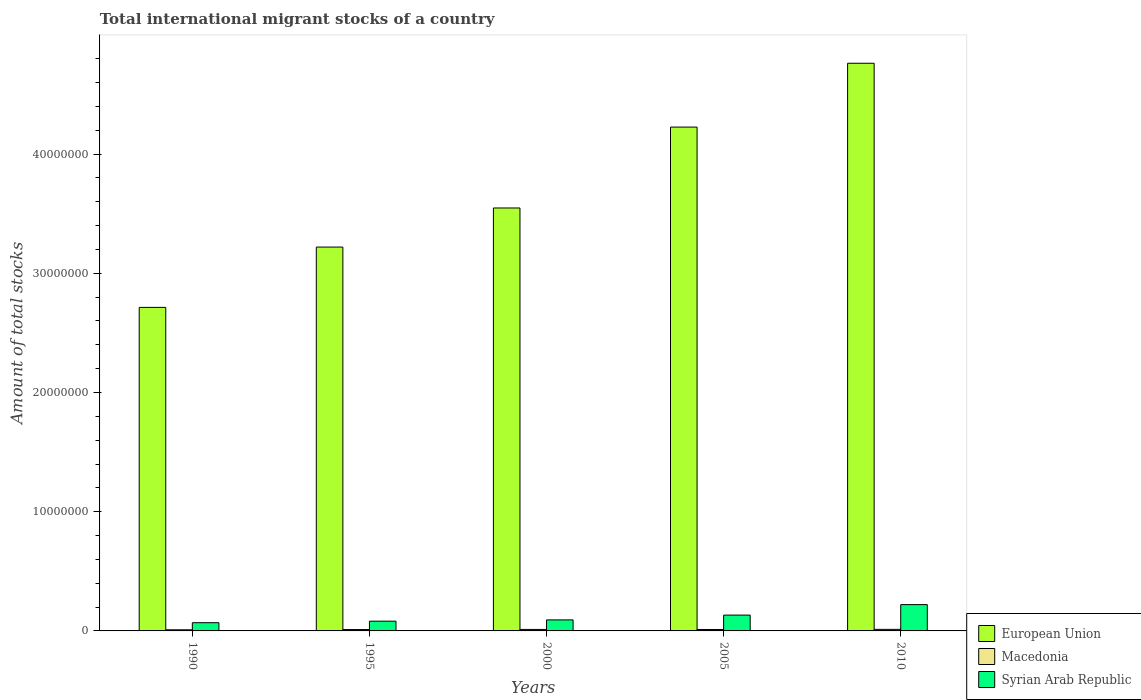How many different coloured bars are there?
Make the answer very short. 3. Are the number of bars per tick equal to the number of legend labels?
Your answer should be compact. Yes. Are the number of bars on each tick of the X-axis equal?
Provide a short and direct response. Yes. How many bars are there on the 2nd tick from the right?
Offer a terse response. 3. What is the amount of total stocks in in Syrian Arab Republic in 1990?
Provide a short and direct response. 6.90e+05. Across all years, what is the maximum amount of total stocks in in Macedonia?
Provide a succinct answer. 1.30e+05. Across all years, what is the minimum amount of total stocks in in Macedonia?
Provide a succinct answer. 9.51e+04. In which year was the amount of total stocks in in European Union minimum?
Give a very brief answer. 1990. What is the total amount of total stocks in in Macedonia in the graph?
Make the answer very short. 5.85e+05. What is the difference between the amount of total stocks in in Syrian Arab Republic in 1995 and that in 2005?
Give a very brief answer. -5.10e+05. What is the difference between the amount of total stocks in in European Union in 2010 and the amount of total stocks in in Macedonia in 1990?
Your response must be concise. 4.75e+07. What is the average amount of total stocks in in European Union per year?
Provide a succinct answer. 3.69e+07. In the year 1995, what is the difference between the amount of total stocks in in European Union and amount of total stocks in in Syrian Arab Republic?
Your response must be concise. 3.14e+07. What is the ratio of the amount of total stocks in in European Union in 1990 to that in 2010?
Offer a terse response. 0.57. Is the amount of total stocks in in European Union in 1990 less than that in 2000?
Give a very brief answer. Yes. Is the difference between the amount of total stocks in in European Union in 2005 and 2010 greater than the difference between the amount of total stocks in in Syrian Arab Republic in 2005 and 2010?
Ensure brevity in your answer.  No. What is the difference between the highest and the second highest amount of total stocks in in Macedonia?
Make the answer very short. 4036. What is the difference between the highest and the lowest amount of total stocks in in Macedonia?
Your answer should be compact. 3.46e+04. What does the 2nd bar from the left in 2005 represents?
Keep it short and to the point. Macedonia. What does the 1st bar from the right in 1990 represents?
Your answer should be very brief. Syrian Arab Republic. What is the difference between two consecutive major ticks on the Y-axis?
Provide a succinct answer. 1.00e+07. Does the graph contain grids?
Make the answer very short. No. How are the legend labels stacked?
Keep it short and to the point. Vertical. What is the title of the graph?
Make the answer very short. Total international migrant stocks of a country. Does "Maldives" appear as one of the legend labels in the graph?
Provide a short and direct response. No. What is the label or title of the X-axis?
Offer a very short reply. Years. What is the label or title of the Y-axis?
Your answer should be very brief. Amount of total stocks. What is the Amount of total stocks of European Union in 1990?
Your response must be concise. 2.71e+07. What is the Amount of total stocks in Macedonia in 1990?
Make the answer very short. 9.51e+04. What is the Amount of total stocks in Syrian Arab Republic in 1990?
Give a very brief answer. 6.90e+05. What is the Amount of total stocks of European Union in 1995?
Provide a short and direct response. 3.22e+07. What is the Amount of total stocks of Macedonia in 1995?
Keep it short and to the point. 1.15e+05. What is the Amount of total stocks in Syrian Arab Republic in 1995?
Offer a terse response. 8.17e+05. What is the Amount of total stocks of European Union in 2000?
Offer a very short reply. 3.55e+07. What is the Amount of total stocks in Macedonia in 2000?
Keep it short and to the point. 1.26e+05. What is the Amount of total stocks of Syrian Arab Republic in 2000?
Make the answer very short. 9.24e+05. What is the Amount of total stocks in European Union in 2005?
Your response must be concise. 4.23e+07. What is the Amount of total stocks in Macedonia in 2005?
Make the answer very short. 1.20e+05. What is the Amount of total stocks of Syrian Arab Republic in 2005?
Your answer should be very brief. 1.33e+06. What is the Amount of total stocks in European Union in 2010?
Make the answer very short. 4.76e+07. What is the Amount of total stocks in Macedonia in 2010?
Keep it short and to the point. 1.30e+05. What is the Amount of total stocks in Syrian Arab Republic in 2010?
Offer a terse response. 2.21e+06. Across all years, what is the maximum Amount of total stocks in European Union?
Offer a very short reply. 4.76e+07. Across all years, what is the maximum Amount of total stocks of Macedonia?
Provide a succinct answer. 1.30e+05. Across all years, what is the maximum Amount of total stocks in Syrian Arab Republic?
Your answer should be compact. 2.21e+06. Across all years, what is the minimum Amount of total stocks in European Union?
Your response must be concise. 2.71e+07. Across all years, what is the minimum Amount of total stocks in Macedonia?
Provide a succinct answer. 9.51e+04. Across all years, what is the minimum Amount of total stocks of Syrian Arab Republic?
Your answer should be very brief. 6.90e+05. What is the total Amount of total stocks in European Union in the graph?
Make the answer very short. 1.85e+08. What is the total Amount of total stocks in Macedonia in the graph?
Offer a very short reply. 5.85e+05. What is the total Amount of total stocks of Syrian Arab Republic in the graph?
Provide a succinct answer. 5.96e+06. What is the difference between the Amount of total stocks in European Union in 1990 and that in 1995?
Offer a terse response. -5.06e+06. What is the difference between the Amount of total stocks in Macedonia in 1990 and that in 1995?
Your answer should be compact. -1.94e+04. What is the difference between the Amount of total stocks of Syrian Arab Republic in 1990 and that in 1995?
Your answer should be very brief. -1.26e+05. What is the difference between the Amount of total stocks in European Union in 1990 and that in 2000?
Your answer should be very brief. -8.34e+06. What is the difference between the Amount of total stocks in Macedonia in 1990 and that in 2000?
Ensure brevity in your answer.  -3.05e+04. What is the difference between the Amount of total stocks in Syrian Arab Republic in 1990 and that in 2000?
Your response must be concise. -2.34e+05. What is the difference between the Amount of total stocks in European Union in 1990 and that in 2005?
Offer a terse response. -1.51e+07. What is the difference between the Amount of total stocks of Macedonia in 1990 and that in 2005?
Your response must be concise. -2.51e+04. What is the difference between the Amount of total stocks of Syrian Arab Republic in 1990 and that in 2005?
Offer a terse response. -6.36e+05. What is the difference between the Amount of total stocks in European Union in 1990 and that in 2010?
Provide a short and direct response. -2.05e+07. What is the difference between the Amount of total stocks of Macedonia in 1990 and that in 2010?
Offer a terse response. -3.46e+04. What is the difference between the Amount of total stocks in Syrian Arab Republic in 1990 and that in 2010?
Your answer should be compact. -1.52e+06. What is the difference between the Amount of total stocks of European Union in 1995 and that in 2000?
Your response must be concise. -3.28e+06. What is the difference between the Amount of total stocks in Macedonia in 1995 and that in 2000?
Offer a terse response. -1.11e+04. What is the difference between the Amount of total stocks in Syrian Arab Republic in 1995 and that in 2000?
Your answer should be very brief. -1.07e+05. What is the difference between the Amount of total stocks in European Union in 1995 and that in 2005?
Ensure brevity in your answer.  -1.01e+07. What is the difference between the Amount of total stocks of Macedonia in 1995 and that in 2005?
Provide a short and direct response. -5765. What is the difference between the Amount of total stocks of Syrian Arab Republic in 1995 and that in 2005?
Keep it short and to the point. -5.10e+05. What is the difference between the Amount of total stocks in European Union in 1995 and that in 2010?
Ensure brevity in your answer.  -1.54e+07. What is the difference between the Amount of total stocks in Macedonia in 1995 and that in 2010?
Your response must be concise. -1.52e+04. What is the difference between the Amount of total stocks in Syrian Arab Republic in 1995 and that in 2010?
Offer a very short reply. -1.39e+06. What is the difference between the Amount of total stocks of European Union in 2000 and that in 2005?
Your answer should be compact. -6.79e+06. What is the difference between the Amount of total stocks in Macedonia in 2000 and that in 2005?
Give a very brief answer. 5377. What is the difference between the Amount of total stocks in Syrian Arab Republic in 2000 and that in 2005?
Ensure brevity in your answer.  -4.02e+05. What is the difference between the Amount of total stocks of European Union in 2000 and that in 2010?
Give a very brief answer. -1.21e+07. What is the difference between the Amount of total stocks in Macedonia in 2000 and that in 2010?
Your answer should be very brief. -4036. What is the difference between the Amount of total stocks of Syrian Arab Republic in 2000 and that in 2010?
Keep it short and to the point. -1.28e+06. What is the difference between the Amount of total stocks in European Union in 2005 and that in 2010?
Offer a terse response. -5.35e+06. What is the difference between the Amount of total stocks in Macedonia in 2005 and that in 2010?
Make the answer very short. -9413. What is the difference between the Amount of total stocks of Syrian Arab Republic in 2005 and that in 2010?
Offer a very short reply. -8.79e+05. What is the difference between the Amount of total stocks in European Union in 1990 and the Amount of total stocks in Macedonia in 1995?
Your response must be concise. 2.70e+07. What is the difference between the Amount of total stocks of European Union in 1990 and the Amount of total stocks of Syrian Arab Republic in 1995?
Make the answer very short. 2.63e+07. What is the difference between the Amount of total stocks in Macedonia in 1990 and the Amount of total stocks in Syrian Arab Republic in 1995?
Keep it short and to the point. -7.22e+05. What is the difference between the Amount of total stocks of European Union in 1990 and the Amount of total stocks of Macedonia in 2000?
Your response must be concise. 2.70e+07. What is the difference between the Amount of total stocks of European Union in 1990 and the Amount of total stocks of Syrian Arab Republic in 2000?
Provide a succinct answer. 2.62e+07. What is the difference between the Amount of total stocks of Macedonia in 1990 and the Amount of total stocks of Syrian Arab Republic in 2000?
Your answer should be very brief. -8.29e+05. What is the difference between the Amount of total stocks of European Union in 1990 and the Amount of total stocks of Macedonia in 2005?
Give a very brief answer. 2.70e+07. What is the difference between the Amount of total stocks of European Union in 1990 and the Amount of total stocks of Syrian Arab Republic in 2005?
Keep it short and to the point. 2.58e+07. What is the difference between the Amount of total stocks of Macedonia in 1990 and the Amount of total stocks of Syrian Arab Republic in 2005?
Offer a terse response. -1.23e+06. What is the difference between the Amount of total stocks in European Union in 1990 and the Amount of total stocks in Macedonia in 2010?
Make the answer very short. 2.70e+07. What is the difference between the Amount of total stocks in European Union in 1990 and the Amount of total stocks in Syrian Arab Republic in 2010?
Provide a short and direct response. 2.49e+07. What is the difference between the Amount of total stocks in Macedonia in 1990 and the Amount of total stocks in Syrian Arab Republic in 2010?
Your answer should be very brief. -2.11e+06. What is the difference between the Amount of total stocks of European Union in 1995 and the Amount of total stocks of Macedonia in 2000?
Your response must be concise. 3.21e+07. What is the difference between the Amount of total stocks in European Union in 1995 and the Amount of total stocks in Syrian Arab Republic in 2000?
Your answer should be compact. 3.13e+07. What is the difference between the Amount of total stocks of Macedonia in 1995 and the Amount of total stocks of Syrian Arab Republic in 2000?
Offer a terse response. -8.10e+05. What is the difference between the Amount of total stocks in European Union in 1995 and the Amount of total stocks in Macedonia in 2005?
Make the answer very short. 3.21e+07. What is the difference between the Amount of total stocks of European Union in 1995 and the Amount of total stocks of Syrian Arab Republic in 2005?
Provide a short and direct response. 3.09e+07. What is the difference between the Amount of total stocks in Macedonia in 1995 and the Amount of total stocks in Syrian Arab Republic in 2005?
Ensure brevity in your answer.  -1.21e+06. What is the difference between the Amount of total stocks in European Union in 1995 and the Amount of total stocks in Macedonia in 2010?
Give a very brief answer. 3.21e+07. What is the difference between the Amount of total stocks in European Union in 1995 and the Amount of total stocks in Syrian Arab Republic in 2010?
Offer a very short reply. 3.00e+07. What is the difference between the Amount of total stocks in Macedonia in 1995 and the Amount of total stocks in Syrian Arab Republic in 2010?
Provide a short and direct response. -2.09e+06. What is the difference between the Amount of total stocks in European Union in 2000 and the Amount of total stocks in Macedonia in 2005?
Offer a very short reply. 3.54e+07. What is the difference between the Amount of total stocks of European Union in 2000 and the Amount of total stocks of Syrian Arab Republic in 2005?
Offer a terse response. 3.41e+07. What is the difference between the Amount of total stocks in Macedonia in 2000 and the Amount of total stocks in Syrian Arab Republic in 2005?
Your answer should be compact. -1.20e+06. What is the difference between the Amount of total stocks in European Union in 2000 and the Amount of total stocks in Macedonia in 2010?
Make the answer very short. 3.53e+07. What is the difference between the Amount of total stocks of European Union in 2000 and the Amount of total stocks of Syrian Arab Republic in 2010?
Your answer should be very brief. 3.33e+07. What is the difference between the Amount of total stocks in Macedonia in 2000 and the Amount of total stocks in Syrian Arab Republic in 2010?
Your answer should be compact. -2.08e+06. What is the difference between the Amount of total stocks in European Union in 2005 and the Amount of total stocks in Macedonia in 2010?
Provide a succinct answer. 4.21e+07. What is the difference between the Amount of total stocks of European Union in 2005 and the Amount of total stocks of Syrian Arab Republic in 2010?
Offer a very short reply. 4.01e+07. What is the difference between the Amount of total stocks of Macedonia in 2005 and the Amount of total stocks of Syrian Arab Republic in 2010?
Offer a very short reply. -2.09e+06. What is the average Amount of total stocks of European Union per year?
Make the answer very short. 3.69e+07. What is the average Amount of total stocks in Macedonia per year?
Ensure brevity in your answer.  1.17e+05. What is the average Amount of total stocks in Syrian Arab Republic per year?
Your response must be concise. 1.19e+06. In the year 1990, what is the difference between the Amount of total stocks in European Union and Amount of total stocks in Macedonia?
Your answer should be compact. 2.70e+07. In the year 1990, what is the difference between the Amount of total stocks in European Union and Amount of total stocks in Syrian Arab Republic?
Provide a short and direct response. 2.64e+07. In the year 1990, what is the difference between the Amount of total stocks in Macedonia and Amount of total stocks in Syrian Arab Republic?
Keep it short and to the point. -5.95e+05. In the year 1995, what is the difference between the Amount of total stocks in European Union and Amount of total stocks in Macedonia?
Your answer should be very brief. 3.21e+07. In the year 1995, what is the difference between the Amount of total stocks in European Union and Amount of total stocks in Syrian Arab Republic?
Your answer should be very brief. 3.14e+07. In the year 1995, what is the difference between the Amount of total stocks of Macedonia and Amount of total stocks of Syrian Arab Republic?
Offer a terse response. -7.02e+05. In the year 2000, what is the difference between the Amount of total stocks of European Union and Amount of total stocks of Macedonia?
Make the answer very short. 3.53e+07. In the year 2000, what is the difference between the Amount of total stocks in European Union and Amount of total stocks in Syrian Arab Republic?
Ensure brevity in your answer.  3.45e+07. In the year 2000, what is the difference between the Amount of total stocks in Macedonia and Amount of total stocks in Syrian Arab Republic?
Ensure brevity in your answer.  -7.98e+05. In the year 2005, what is the difference between the Amount of total stocks of European Union and Amount of total stocks of Macedonia?
Ensure brevity in your answer.  4.21e+07. In the year 2005, what is the difference between the Amount of total stocks in European Union and Amount of total stocks in Syrian Arab Republic?
Give a very brief answer. 4.09e+07. In the year 2005, what is the difference between the Amount of total stocks of Macedonia and Amount of total stocks of Syrian Arab Republic?
Keep it short and to the point. -1.21e+06. In the year 2010, what is the difference between the Amount of total stocks of European Union and Amount of total stocks of Macedonia?
Keep it short and to the point. 4.75e+07. In the year 2010, what is the difference between the Amount of total stocks in European Union and Amount of total stocks in Syrian Arab Republic?
Provide a succinct answer. 4.54e+07. In the year 2010, what is the difference between the Amount of total stocks of Macedonia and Amount of total stocks of Syrian Arab Republic?
Your answer should be very brief. -2.08e+06. What is the ratio of the Amount of total stocks of European Union in 1990 to that in 1995?
Offer a very short reply. 0.84. What is the ratio of the Amount of total stocks in Macedonia in 1990 to that in 1995?
Provide a succinct answer. 0.83. What is the ratio of the Amount of total stocks of Syrian Arab Republic in 1990 to that in 1995?
Your answer should be very brief. 0.85. What is the ratio of the Amount of total stocks of European Union in 1990 to that in 2000?
Give a very brief answer. 0.77. What is the ratio of the Amount of total stocks in Macedonia in 1990 to that in 2000?
Provide a succinct answer. 0.76. What is the ratio of the Amount of total stocks in Syrian Arab Republic in 1990 to that in 2000?
Ensure brevity in your answer.  0.75. What is the ratio of the Amount of total stocks of European Union in 1990 to that in 2005?
Ensure brevity in your answer.  0.64. What is the ratio of the Amount of total stocks in Macedonia in 1990 to that in 2005?
Your response must be concise. 0.79. What is the ratio of the Amount of total stocks of Syrian Arab Republic in 1990 to that in 2005?
Give a very brief answer. 0.52. What is the ratio of the Amount of total stocks in European Union in 1990 to that in 2010?
Offer a terse response. 0.57. What is the ratio of the Amount of total stocks of Macedonia in 1990 to that in 2010?
Make the answer very short. 0.73. What is the ratio of the Amount of total stocks in Syrian Arab Republic in 1990 to that in 2010?
Keep it short and to the point. 0.31. What is the ratio of the Amount of total stocks in European Union in 1995 to that in 2000?
Make the answer very short. 0.91. What is the ratio of the Amount of total stocks of Macedonia in 1995 to that in 2000?
Make the answer very short. 0.91. What is the ratio of the Amount of total stocks in Syrian Arab Republic in 1995 to that in 2000?
Offer a very short reply. 0.88. What is the ratio of the Amount of total stocks in European Union in 1995 to that in 2005?
Offer a very short reply. 0.76. What is the ratio of the Amount of total stocks in Macedonia in 1995 to that in 2005?
Your response must be concise. 0.95. What is the ratio of the Amount of total stocks in Syrian Arab Republic in 1995 to that in 2005?
Provide a succinct answer. 0.62. What is the ratio of the Amount of total stocks of European Union in 1995 to that in 2010?
Give a very brief answer. 0.68. What is the ratio of the Amount of total stocks of Macedonia in 1995 to that in 2010?
Provide a succinct answer. 0.88. What is the ratio of the Amount of total stocks in Syrian Arab Republic in 1995 to that in 2010?
Make the answer very short. 0.37. What is the ratio of the Amount of total stocks of European Union in 2000 to that in 2005?
Make the answer very short. 0.84. What is the ratio of the Amount of total stocks of Macedonia in 2000 to that in 2005?
Provide a short and direct response. 1.04. What is the ratio of the Amount of total stocks in Syrian Arab Republic in 2000 to that in 2005?
Offer a terse response. 0.7. What is the ratio of the Amount of total stocks of European Union in 2000 to that in 2010?
Ensure brevity in your answer.  0.75. What is the ratio of the Amount of total stocks in Macedonia in 2000 to that in 2010?
Your response must be concise. 0.97. What is the ratio of the Amount of total stocks of Syrian Arab Republic in 2000 to that in 2010?
Your answer should be very brief. 0.42. What is the ratio of the Amount of total stocks of European Union in 2005 to that in 2010?
Keep it short and to the point. 0.89. What is the ratio of the Amount of total stocks in Macedonia in 2005 to that in 2010?
Your response must be concise. 0.93. What is the ratio of the Amount of total stocks in Syrian Arab Republic in 2005 to that in 2010?
Your answer should be very brief. 0.6. What is the difference between the highest and the second highest Amount of total stocks of European Union?
Your answer should be compact. 5.35e+06. What is the difference between the highest and the second highest Amount of total stocks of Macedonia?
Offer a very short reply. 4036. What is the difference between the highest and the second highest Amount of total stocks of Syrian Arab Republic?
Offer a terse response. 8.79e+05. What is the difference between the highest and the lowest Amount of total stocks in European Union?
Your response must be concise. 2.05e+07. What is the difference between the highest and the lowest Amount of total stocks in Macedonia?
Ensure brevity in your answer.  3.46e+04. What is the difference between the highest and the lowest Amount of total stocks in Syrian Arab Republic?
Ensure brevity in your answer.  1.52e+06. 